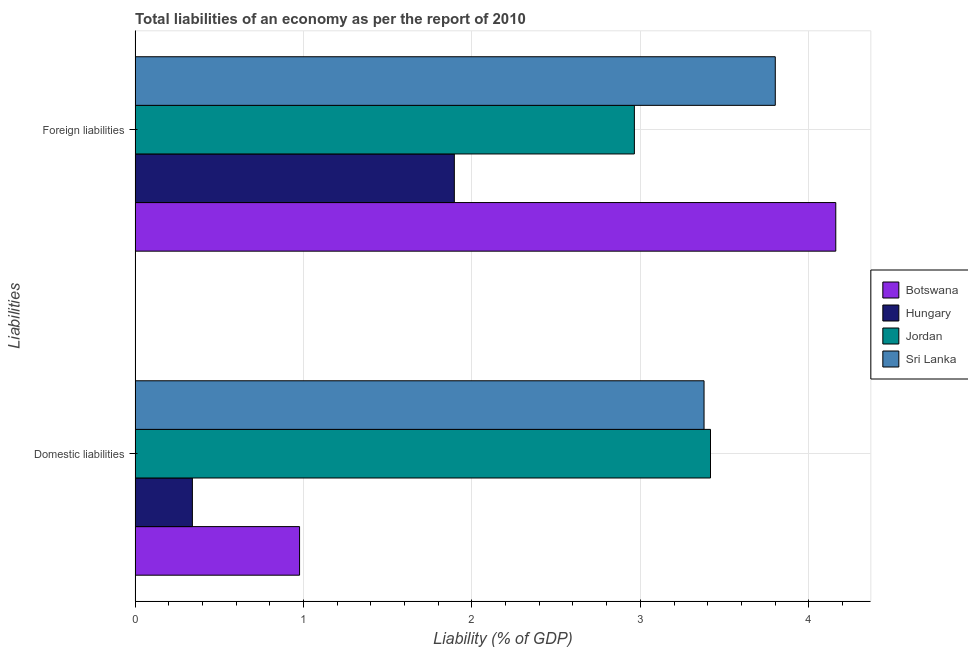How many groups of bars are there?
Ensure brevity in your answer.  2. Are the number of bars on each tick of the Y-axis equal?
Ensure brevity in your answer.  Yes. How many bars are there on the 1st tick from the top?
Your answer should be very brief. 4. What is the label of the 2nd group of bars from the top?
Give a very brief answer. Domestic liabilities. What is the incurrence of foreign liabilities in Botswana?
Make the answer very short. 4.16. Across all countries, what is the maximum incurrence of foreign liabilities?
Your answer should be very brief. 4.16. Across all countries, what is the minimum incurrence of foreign liabilities?
Provide a succinct answer. 1.9. In which country was the incurrence of domestic liabilities maximum?
Offer a very short reply. Jordan. In which country was the incurrence of domestic liabilities minimum?
Ensure brevity in your answer.  Hungary. What is the total incurrence of domestic liabilities in the graph?
Make the answer very short. 8.11. What is the difference between the incurrence of foreign liabilities in Hungary and that in Sri Lanka?
Make the answer very short. -1.91. What is the difference between the incurrence of domestic liabilities in Hungary and the incurrence of foreign liabilities in Jordan?
Offer a terse response. -2.62. What is the average incurrence of domestic liabilities per country?
Make the answer very short. 2.03. What is the difference between the incurrence of foreign liabilities and incurrence of domestic liabilities in Botswana?
Offer a terse response. 3.18. In how many countries, is the incurrence of domestic liabilities greater than 4 %?
Provide a short and direct response. 0. What is the ratio of the incurrence of domestic liabilities in Jordan to that in Hungary?
Make the answer very short. 10.04. Is the incurrence of foreign liabilities in Hungary less than that in Botswana?
Give a very brief answer. Yes. In how many countries, is the incurrence of domestic liabilities greater than the average incurrence of domestic liabilities taken over all countries?
Ensure brevity in your answer.  2. What does the 4th bar from the top in Domestic liabilities represents?
Make the answer very short. Botswana. What does the 4th bar from the bottom in Foreign liabilities represents?
Your response must be concise. Sri Lanka. How many bars are there?
Provide a succinct answer. 8. How many countries are there in the graph?
Offer a terse response. 4. Are the values on the major ticks of X-axis written in scientific E-notation?
Provide a succinct answer. No. Does the graph contain grids?
Keep it short and to the point. Yes. Where does the legend appear in the graph?
Offer a terse response. Center right. What is the title of the graph?
Your answer should be very brief. Total liabilities of an economy as per the report of 2010. Does "West Bank and Gaza" appear as one of the legend labels in the graph?
Make the answer very short. No. What is the label or title of the X-axis?
Give a very brief answer. Liability (% of GDP). What is the label or title of the Y-axis?
Your answer should be compact. Liabilities. What is the Liability (% of GDP) in Botswana in Domestic liabilities?
Your answer should be compact. 0.98. What is the Liability (% of GDP) of Hungary in Domestic liabilities?
Make the answer very short. 0.34. What is the Liability (% of GDP) in Jordan in Domestic liabilities?
Your answer should be compact. 3.42. What is the Liability (% of GDP) in Sri Lanka in Domestic liabilities?
Provide a short and direct response. 3.38. What is the Liability (% of GDP) of Botswana in Foreign liabilities?
Offer a terse response. 4.16. What is the Liability (% of GDP) of Hungary in Foreign liabilities?
Your answer should be compact. 1.9. What is the Liability (% of GDP) of Jordan in Foreign liabilities?
Your answer should be very brief. 2.96. What is the Liability (% of GDP) in Sri Lanka in Foreign liabilities?
Provide a short and direct response. 3.8. Across all Liabilities, what is the maximum Liability (% of GDP) in Botswana?
Make the answer very short. 4.16. Across all Liabilities, what is the maximum Liability (% of GDP) in Hungary?
Offer a terse response. 1.9. Across all Liabilities, what is the maximum Liability (% of GDP) in Jordan?
Offer a very short reply. 3.42. Across all Liabilities, what is the maximum Liability (% of GDP) of Sri Lanka?
Keep it short and to the point. 3.8. Across all Liabilities, what is the minimum Liability (% of GDP) in Botswana?
Your response must be concise. 0.98. Across all Liabilities, what is the minimum Liability (% of GDP) of Hungary?
Keep it short and to the point. 0.34. Across all Liabilities, what is the minimum Liability (% of GDP) in Jordan?
Provide a short and direct response. 2.96. Across all Liabilities, what is the minimum Liability (% of GDP) in Sri Lanka?
Offer a very short reply. 3.38. What is the total Liability (% of GDP) in Botswana in the graph?
Your answer should be compact. 5.14. What is the total Liability (% of GDP) of Hungary in the graph?
Keep it short and to the point. 2.24. What is the total Liability (% of GDP) in Jordan in the graph?
Your answer should be compact. 6.38. What is the total Liability (% of GDP) of Sri Lanka in the graph?
Your answer should be very brief. 7.18. What is the difference between the Liability (% of GDP) of Botswana in Domestic liabilities and that in Foreign liabilities?
Keep it short and to the point. -3.18. What is the difference between the Liability (% of GDP) in Hungary in Domestic liabilities and that in Foreign liabilities?
Keep it short and to the point. -1.56. What is the difference between the Liability (% of GDP) of Jordan in Domestic liabilities and that in Foreign liabilities?
Ensure brevity in your answer.  0.45. What is the difference between the Liability (% of GDP) of Sri Lanka in Domestic liabilities and that in Foreign liabilities?
Provide a short and direct response. -0.42. What is the difference between the Liability (% of GDP) of Botswana in Domestic liabilities and the Liability (% of GDP) of Hungary in Foreign liabilities?
Your answer should be compact. -0.92. What is the difference between the Liability (% of GDP) of Botswana in Domestic liabilities and the Liability (% of GDP) of Jordan in Foreign liabilities?
Provide a short and direct response. -1.99. What is the difference between the Liability (% of GDP) in Botswana in Domestic liabilities and the Liability (% of GDP) in Sri Lanka in Foreign liabilities?
Your answer should be compact. -2.82. What is the difference between the Liability (% of GDP) in Hungary in Domestic liabilities and the Liability (% of GDP) in Jordan in Foreign liabilities?
Give a very brief answer. -2.62. What is the difference between the Liability (% of GDP) of Hungary in Domestic liabilities and the Liability (% of GDP) of Sri Lanka in Foreign liabilities?
Give a very brief answer. -3.46. What is the difference between the Liability (% of GDP) of Jordan in Domestic liabilities and the Liability (% of GDP) of Sri Lanka in Foreign liabilities?
Keep it short and to the point. -0.38. What is the average Liability (% of GDP) of Botswana per Liabilities?
Provide a succinct answer. 2.57. What is the average Liability (% of GDP) in Hungary per Liabilities?
Your answer should be compact. 1.12. What is the average Liability (% of GDP) of Jordan per Liabilities?
Your answer should be compact. 3.19. What is the average Liability (% of GDP) in Sri Lanka per Liabilities?
Make the answer very short. 3.59. What is the difference between the Liability (% of GDP) in Botswana and Liability (% of GDP) in Hungary in Domestic liabilities?
Your response must be concise. 0.64. What is the difference between the Liability (% of GDP) in Botswana and Liability (% of GDP) in Jordan in Domestic liabilities?
Keep it short and to the point. -2.44. What is the difference between the Liability (% of GDP) of Botswana and Liability (% of GDP) of Sri Lanka in Domestic liabilities?
Give a very brief answer. -2.4. What is the difference between the Liability (% of GDP) in Hungary and Liability (% of GDP) in Jordan in Domestic liabilities?
Offer a terse response. -3.08. What is the difference between the Liability (% of GDP) in Hungary and Liability (% of GDP) in Sri Lanka in Domestic liabilities?
Your answer should be compact. -3.04. What is the difference between the Liability (% of GDP) in Jordan and Liability (% of GDP) in Sri Lanka in Domestic liabilities?
Make the answer very short. 0.04. What is the difference between the Liability (% of GDP) in Botswana and Liability (% of GDP) in Hungary in Foreign liabilities?
Make the answer very short. 2.26. What is the difference between the Liability (% of GDP) of Botswana and Liability (% of GDP) of Jordan in Foreign liabilities?
Offer a terse response. 1.2. What is the difference between the Liability (% of GDP) in Botswana and Liability (% of GDP) in Sri Lanka in Foreign liabilities?
Offer a very short reply. 0.36. What is the difference between the Liability (% of GDP) of Hungary and Liability (% of GDP) of Jordan in Foreign liabilities?
Your response must be concise. -1.07. What is the difference between the Liability (% of GDP) in Hungary and Liability (% of GDP) in Sri Lanka in Foreign liabilities?
Your response must be concise. -1.91. What is the difference between the Liability (% of GDP) in Jordan and Liability (% of GDP) in Sri Lanka in Foreign liabilities?
Give a very brief answer. -0.84. What is the ratio of the Liability (% of GDP) of Botswana in Domestic liabilities to that in Foreign liabilities?
Keep it short and to the point. 0.23. What is the ratio of the Liability (% of GDP) of Hungary in Domestic liabilities to that in Foreign liabilities?
Provide a short and direct response. 0.18. What is the ratio of the Liability (% of GDP) in Jordan in Domestic liabilities to that in Foreign liabilities?
Keep it short and to the point. 1.15. What is the ratio of the Liability (% of GDP) in Sri Lanka in Domestic liabilities to that in Foreign liabilities?
Give a very brief answer. 0.89. What is the difference between the highest and the second highest Liability (% of GDP) of Botswana?
Offer a very short reply. 3.18. What is the difference between the highest and the second highest Liability (% of GDP) of Hungary?
Make the answer very short. 1.56. What is the difference between the highest and the second highest Liability (% of GDP) in Jordan?
Provide a short and direct response. 0.45. What is the difference between the highest and the second highest Liability (% of GDP) of Sri Lanka?
Provide a succinct answer. 0.42. What is the difference between the highest and the lowest Liability (% of GDP) in Botswana?
Your response must be concise. 3.18. What is the difference between the highest and the lowest Liability (% of GDP) of Hungary?
Keep it short and to the point. 1.56. What is the difference between the highest and the lowest Liability (% of GDP) of Jordan?
Your response must be concise. 0.45. What is the difference between the highest and the lowest Liability (% of GDP) in Sri Lanka?
Make the answer very short. 0.42. 